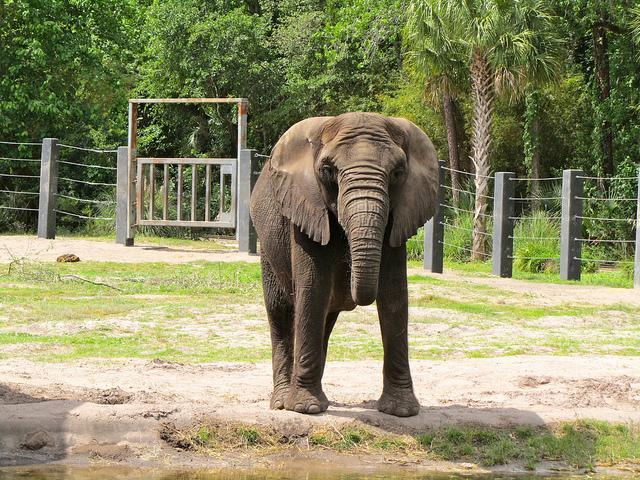How many animals are pictured?
Give a very brief answer. 1. 